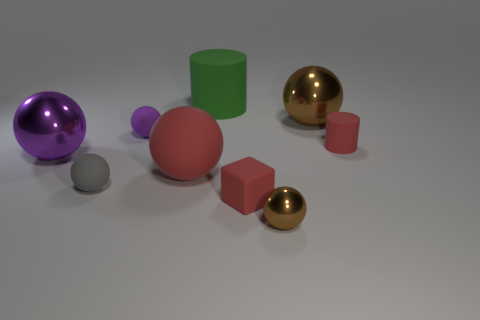Subtract all gray balls. How many balls are left? 5 Subtract all large red spheres. How many spheres are left? 5 Subtract all cyan spheres. Subtract all brown cubes. How many spheres are left? 6 Add 1 big green objects. How many objects exist? 10 Subtract all cylinders. How many objects are left? 7 Add 8 gray spheres. How many gray spheres exist? 9 Subtract 1 gray balls. How many objects are left? 8 Subtract all big purple metal balls. Subtract all brown metal balls. How many objects are left? 6 Add 9 tiny red rubber cylinders. How many tiny red rubber cylinders are left? 10 